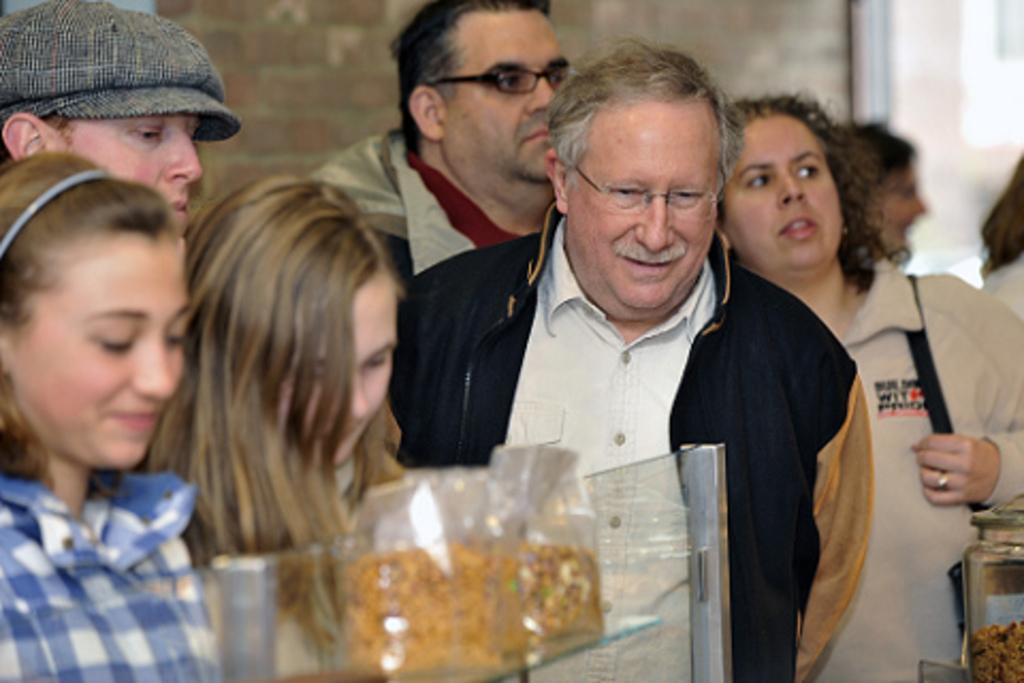What is happening in the image? There are persons standing in the image. What can be seen in the background of the image? There are pet jars and a wall visible in the background of the image. What type of bread is being delivered by the person in the image? There is no person delivering bread in the image, nor is there any bread present. 